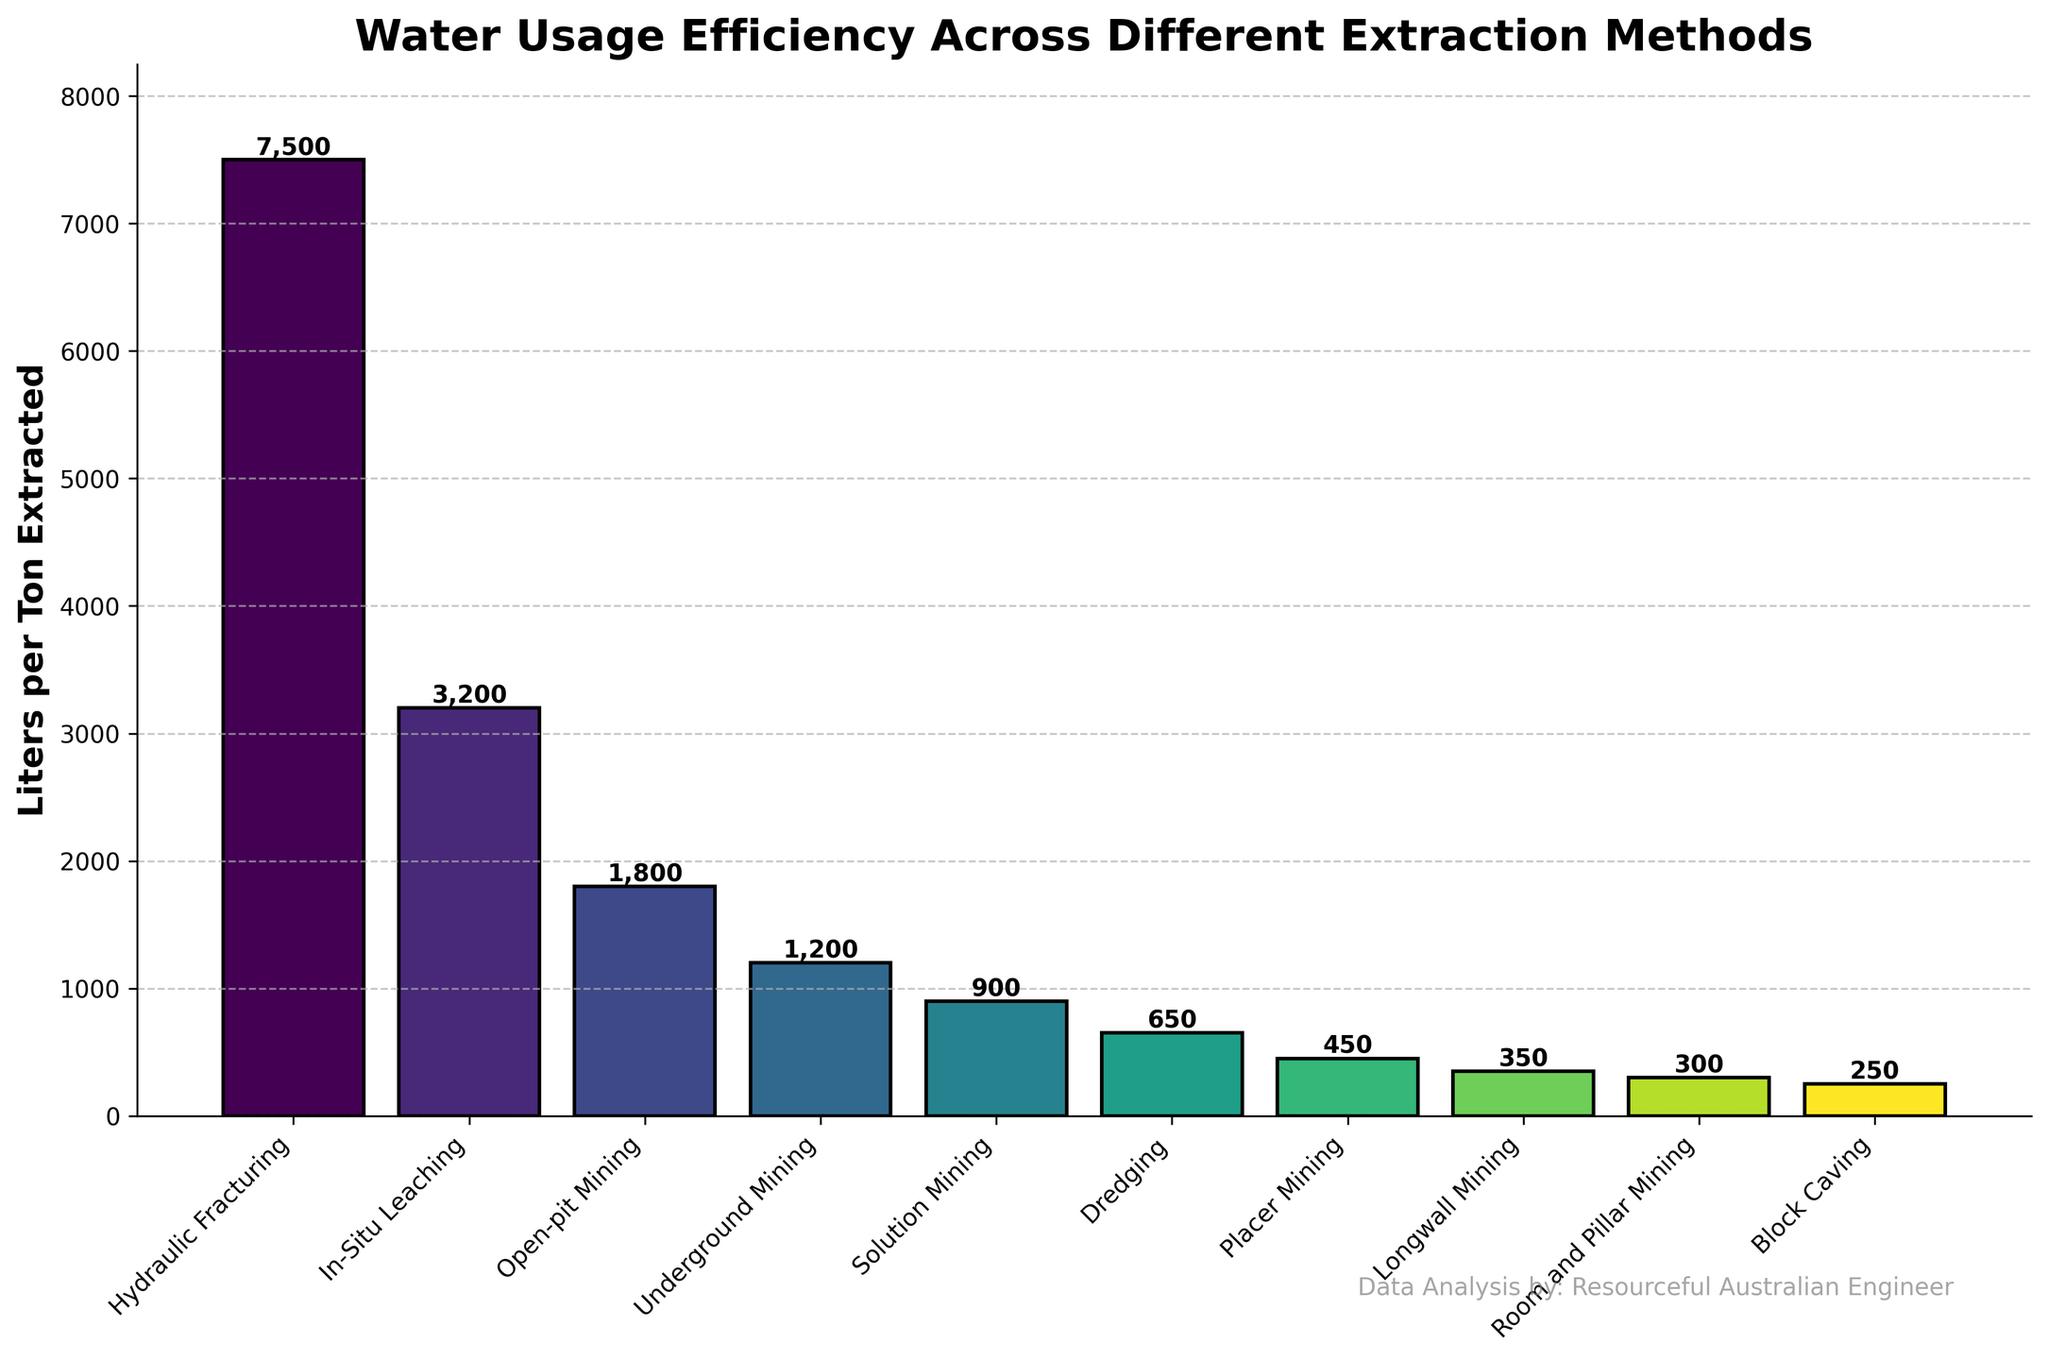Which extraction method uses the most water per ton extracted? By looking at the heights of the bars, the tallest bar represents the method that uses the most water. The tallest bar belongs to Hydraulic Fracturing.
Answer: Hydraulic Fracturing Which extraction method uses the least water per ton extracted? By examining the shortest bar, we can identify the method that uses the least water. The shortest bar represents Block Caving.
Answer: Block Caving How much more water does Hydraulic Fracturing use compared to In-Situ Leaching per ton extracted? The bar heights for Hydraulic Fracturing and In-Situ Leaching show their respective water usage. Subtract the lower value (In-Situ Leaching at 3200) from the higher value (Hydraulic Fracturing at 7500). 7500 - 3200 = 4300.
Answer: 4300 How many extraction methods use less than 1000 liters per ton extracted? Count the number of bars representing methods with water usage values less than 1000. These methods are Solution Mining, Dredging, Placer Mining, Longwall Mining, Room and Pillar Mining, and Block Caving, making a total of 6 methods.
Answer: 6 What is the average water usage per ton extracted among Open-pit Mining, Underground Mining, and Solution Mining? Add the water usage for these three methods and divide by the number of methods. (1800 + 1200 + 900) / 3 = 3900 / 3 = 1300.
Answer: 1300 Which extraction methods have water usage values between 300 and 1000 liters per ton extracted? Identify the bars within the 300 to 1000 range. These methods are Solution Mining (900), Dredging (650), Placer Mining (450), and Longwall Mining (350).
Answer: Solution Mining, Dredging, Placer Mining, Longwall Mining What is the combined water usage per ton extracted for Placer Mining and Open-pit Mining? Add the water usage values for Placer Mining and Open-pit Mining. 450 + 1800 = 2250.
Answer: 2250 How does the water usage for Room and Pillar Mining compare to Block Caving in terms of percentage increase? Calculate the difference between Room and Pillar Mining and Block Caving, then divide by Block Caving and multiply by 100 for the percentage. (300 - 250) / 250 * 100 = 50 / 250 * 100 = 20%.
Answer: 20% What is the median value of water usage per ton extracted across all methods? List all the water usage values in ascending order and find the median, the middle value in an ordered list of 10 numbers: [250, 300, 350, 450, 650, 900, 1200, 1800, 3200, 7500]. The median is the average of the 5th and 6th values: (650 + 900) / 2 = 1550 / 2 = 775.
Answer: 775 